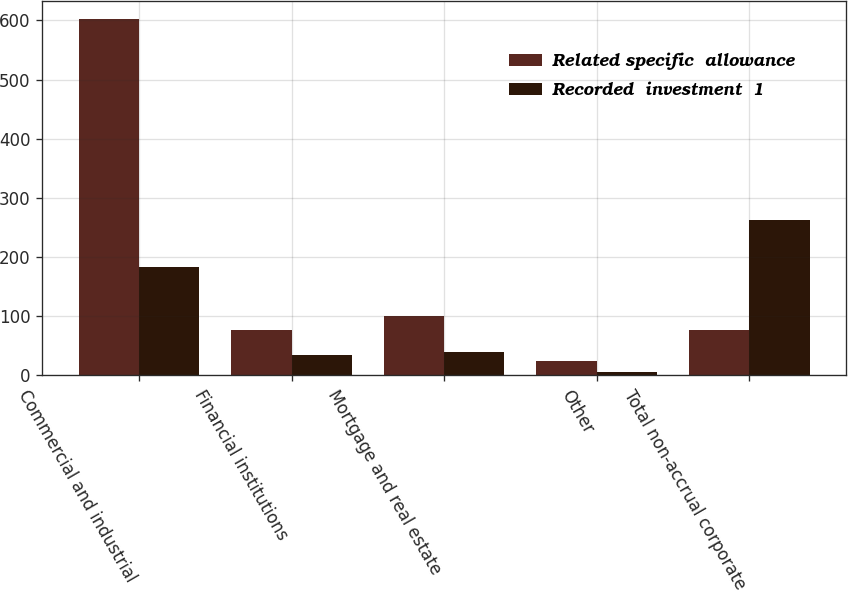Convert chart. <chart><loc_0><loc_0><loc_500><loc_500><stacked_bar_chart><ecel><fcel>Commercial and industrial<fcel>Financial institutions<fcel>Mortgage and real estate<fcel>Other<fcel>Total non-accrual corporate<nl><fcel>Related specific  allowance<fcel>603<fcel>76<fcel>100<fcel>24<fcel>76<nl><fcel>Recorded  investment  1<fcel>183<fcel>35<fcel>39<fcel>6<fcel>263<nl></chart> 